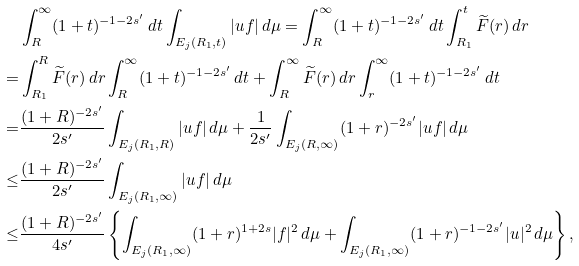Convert formula to latex. <formula><loc_0><loc_0><loc_500><loc_500>& \int _ { R } ^ { \infty } ( 1 + t ) ^ { - 1 - 2 s ^ { \prime } } \, d t \int _ { E _ { j } ( R _ { 1 } , t ) } | u f | \, d \mu = \int _ { R } ^ { \infty } ( 1 + t ) ^ { - 1 - 2 s ^ { \prime } } \, d t \int _ { R _ { 1 } } ^ { t } \widetilde { F } ( r ) \, d r \\ = & \int _ { R _ { 1 } } ^ { R } \widetilde { F } ( r ) \, d r \int _ { R } ^ { \infty } ( 1 + t ) ^ { - 1 - 2 s ^ { \prime } } \, d t + \int _ { R } ^ { \infty } \widetilde { F } ( r ) \, d r \int _ { r } ^ { \infty } ( 1 + t ) ^ { - 1 - 2 s ^ { \prime } } \, d t \\ = & \frac { ( 1 + R ) ^ { - 2 s ^ { \prime } } } { 2 s ^ { \prime } } \int _ { E _ { j } ( R _ { 1 } , R ) } | u f | \, d \mu + \frac { 1 } { 2 s ^ { \prime } } \int _ { E _ { j } ( R , \infty ) } ( 1 + r ) ^ { - 2 s ^ { \prime } } | u f | \, d \mu \\ \leq & \frac { ( 1 + R ) ^ { - 2 s ^ { \prime } } } { 2 s ^ { \prime } } \int _ { E _ { j } ( R _ { 1 } , \infty ) } | u f | \, d \mu \\ \leq & \frac { ( 1 + R ) ^ { - 2 s ^ { \prime } } } { 4 s ^ { \prime } } \left \{ \int _ { E _ { j } ( R _ { 1 } , \infty ) } ( 1 + r ) ^ { 1 + 2 s } | f | ^ { 2 } \, d \mu + \int _ { E _ { j } ( R _ { 1 } , \infty ) } ( 1 + r ) ^ { - 1 - 2 s ^ { \prime } } | u | ^ { 2 } \, d \mu \right \} ,</formula> 